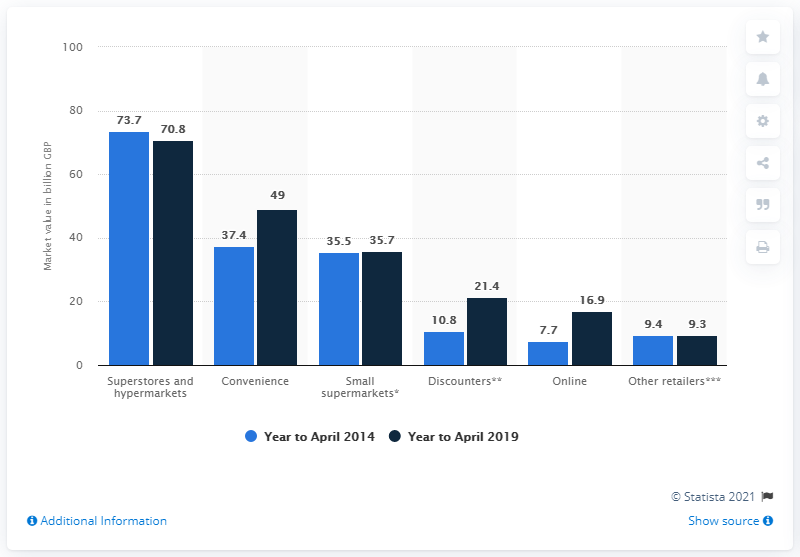Highlight a few significant elements in this photo. In April 2014, the value of superstores and hypermarkets was 73.7 billion U.S. dollars. 